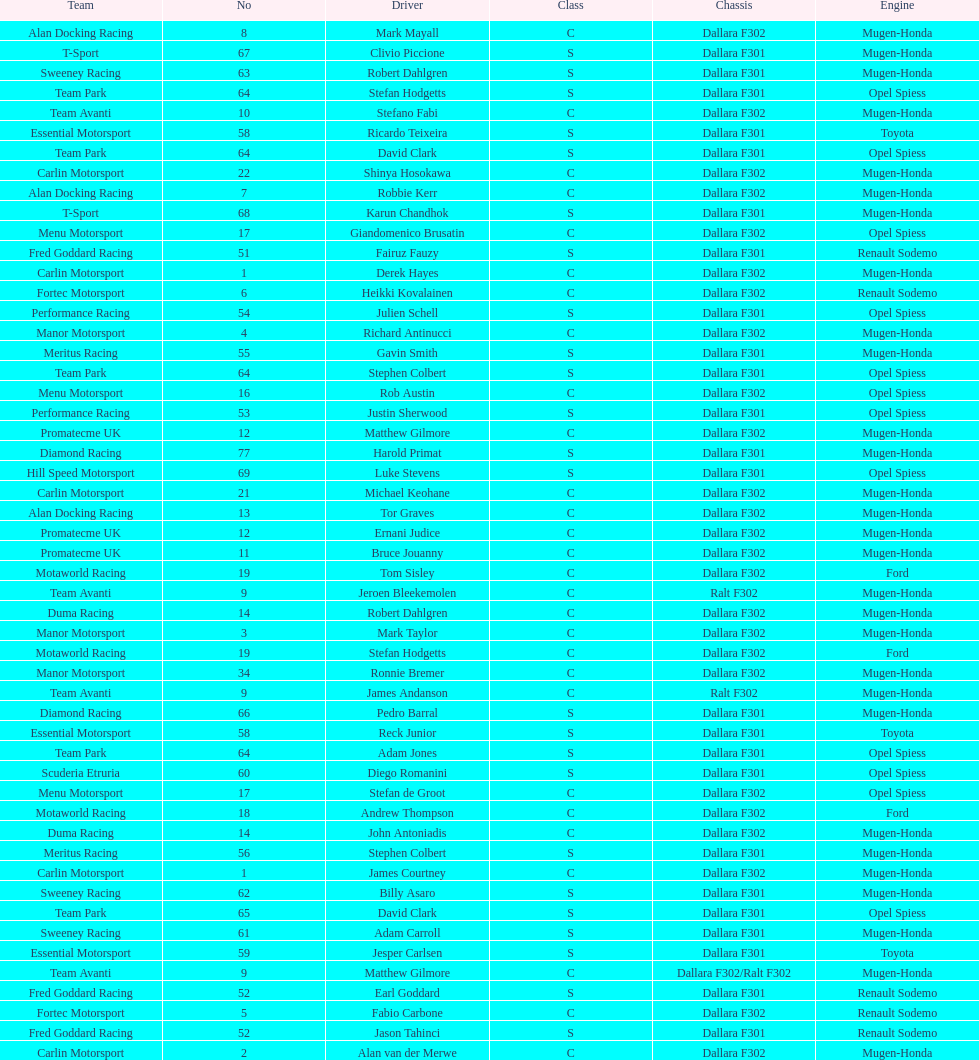What is the number of teams that had drivers all from the same country? 4. 